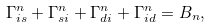Convert formula to latex. <formula><loc_0><loc_0><loc_500><loc_500>\Gamma ^ { n } _ { i s } + \Gamma ^ { n } _ { s i } + \Gamma ^ { n } _ { d i } + \Gamma ^ { n } _ { i d } = B _ { n } ,</formula> 